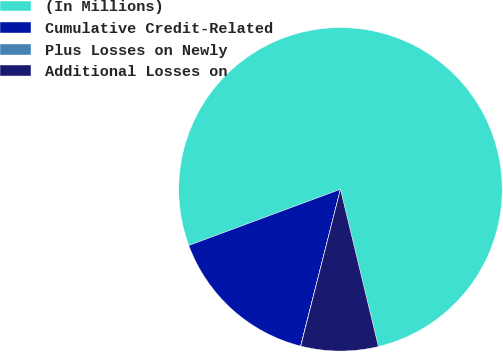Convert chart. <chart><loc_0><loc_0><loc_500><loc_500><pie_chart><fcel>(In Millions)<fcel>Cumulative Credit-Related<fcel>Plus Losses on Newly<fcel>Additional Losses on<nl><fcel>76.88%<fcel>15.39%<fcel>0.02%<fcel>7.71%<nl></chart> 